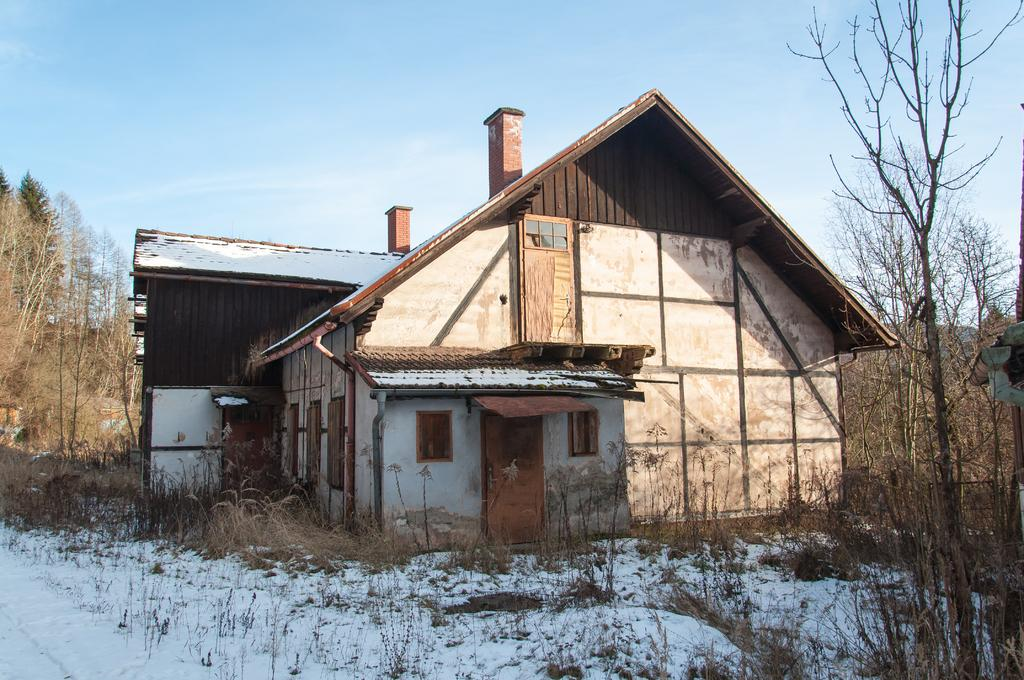What type of structure is present in the image? There is a house in the image. What are the main features of the house? The house has walls, a door, and windows. What is the weather like in the image? There is snow visible in the image, indicating a cold or wintry environment. What type of vegetation can be seen in the image? There are plants and trees in the image. What is visible in the background of the image? The sky is visible in the background of the image, and there are pillars in the background as well. What type of acoustics can be heard in the image? There is no sound or acoustics present in the image, as it is a still photograph. Can you see a trail leading to the house in the image? There is no trail visible in the image; it only shows the house, vegetation, and background elements. 